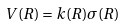Convert formula to latex. <formula><loc_0><loc_0><loc_500><loc_500>V ( R ) = k ( R ) \sigma ( R )</formula> 